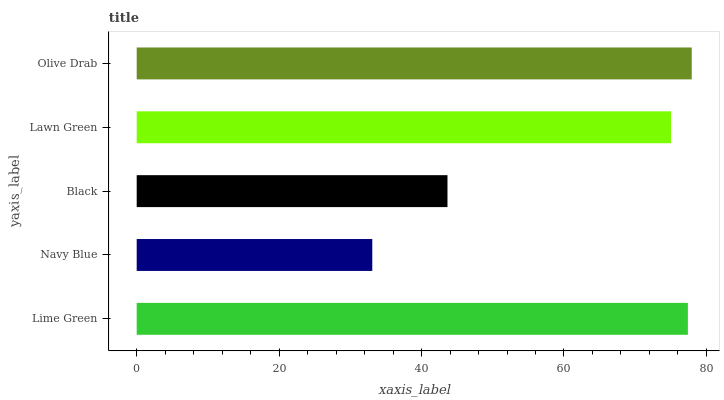Is Navy Blue the minimum?
Answer yes or no. Yes. Is Olive Drab the maximum?
Answer yes or no. Yes. Is Black the minimum?
Answer yes or no. No. Is Black the maximum?
Answer yes or no. No. Is Black greater than Navy Blue?
Answer yes or no. Yes. Is Navy Blue less than Black?
Answer yes or no. Yes. Is Navy Blue greater than Black?
Answer yes or no. No. Is Black less than Navy Blue?
Answer yes or no. No. Is Lawn Green the high median?
Answer yes or no. Yes. Is Lawn Green the low median?
Answer yes or no. Yes. Is Navy Blue the high median?
Answer yes or no. No. Is Navy Blue the low median?
Answer yes or no. No. 